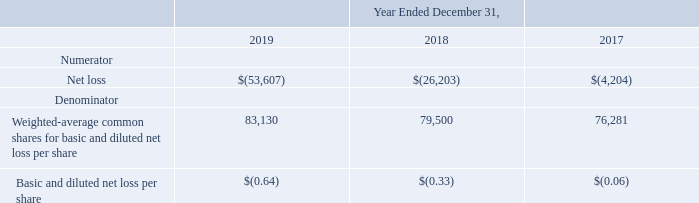Note 13. Basic and Diluted Net Loss Per Share
Basic net loss per share is computed by dividing the net loss by the weighted-average number of shares of common stock outstanding during the period, less the weighted-average unvested common stock subject to repurchase or forfeiture as they are not deemed to be issued for accounting purposes. Diluted net loss per share is computed by giving effect to all potential shares of common stock, stock options, restricted stock units, ESPP, and convertible senior notes, to the extent dilutive. For the periods presented, all such common stock equivalents have been excluded from diluted net loss per share as the effect to net loss per share would be anti-dilutive.
The following table sets forth the computation of the Company’s basic and diluted net loss per share during the years ended December 31, 2019, 2018 and 2017 (in thousands, except per share data)
What are the respective weighted-average common shares for basic and diluted net loss per share in 2017 and 2018?
Answer scale should be: thousand. 76,281, 79,500. What are the respective eighted-average common shares for basic and diluted net loss per share in 2018 and 2019?
Answer scale should be: thousand. 79,500, 83,130. What are the respective basic and diluted net loss per share in 2017 and 2018? (0.06), (0.33). What is the change in the weighted-average common shares for basic and diluted net loss per share between 2017 and 2018?
Answer scale should be: thousand. 79,500 - 76,281 
Answer: 3219. What is the percentage change in the weighted-average common shares for basic and diluted net loss per share between 2017 and 2018?
Answer scale should be: percent. (79,500 - 76,281)/76,281 
Answer: 4.22. What is the percentage change in the weighted-average common shares for basic and diluted net loss per share between 2018 and 2019?
Answer scale should be: percent. (83,130 - 79,500)/79,500 
Answer: 4.57. 